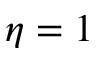<formula> <loc_0><loc_0><loc_500><loc_500>\eta = 1</formula> 